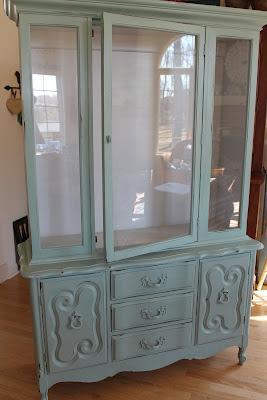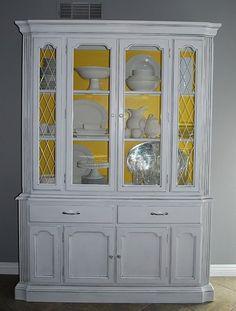The first image is the image on the left, the second image is the image on the right. Evaluate the accuracy of this statement regarding the images: "One image shows a pale blue shabby chic cabinet with a shaped element on top and a two-handled drawer under the glass doors.". Is it true? Answer yes or no. No. The first image is the image on the left, the second image is the image on the right. Assess this claim about the two images: "A wooded hutch with a curved top stands on feet, while a second hutch has a straight top and sits flush to the floor.". Correct or not? Answer yes or no. No. 